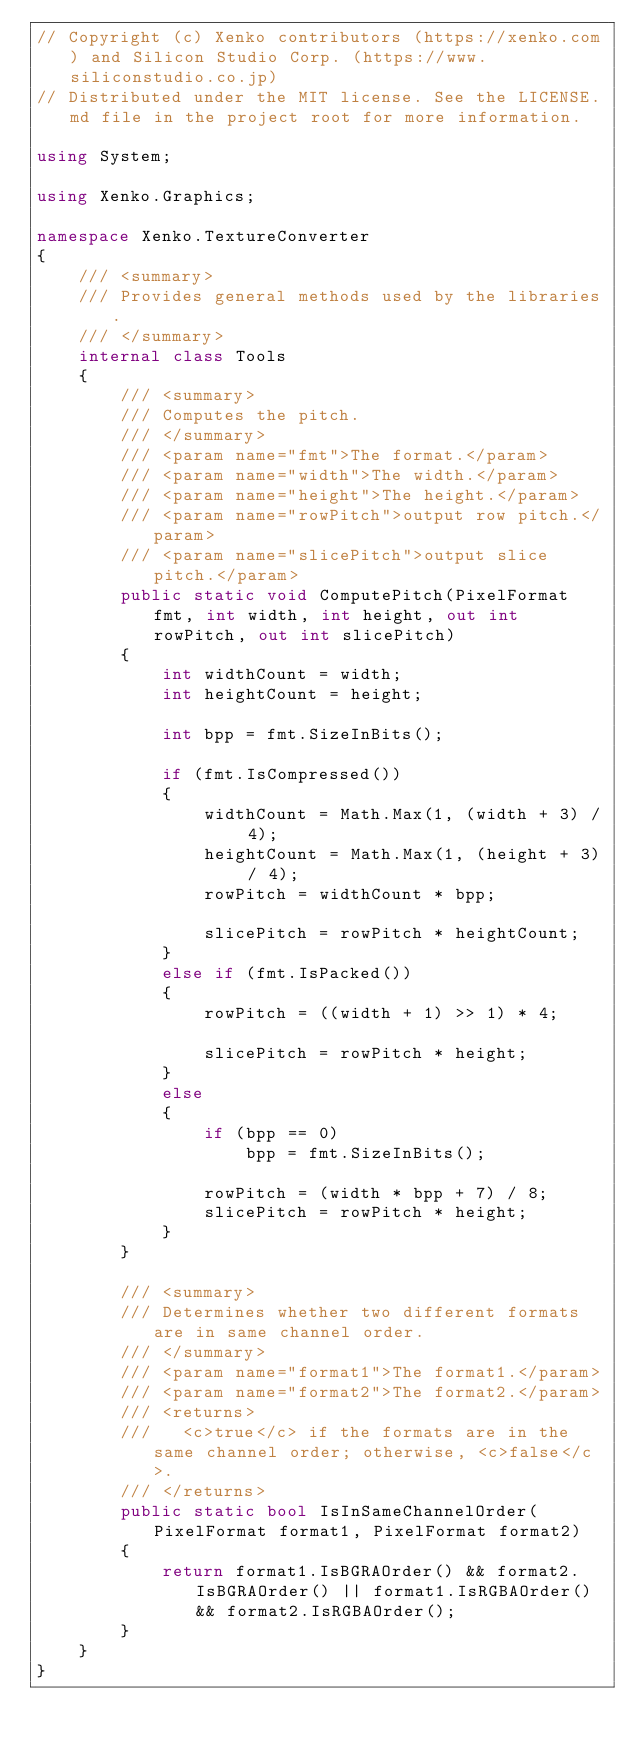<code> <loc_0><loc_0><loc_500><loc_500><_C#_>// Copyright (c) Xenko contributors (https://xenko.com) and Silicon Studio Corp. (https://www.siliconstudio.co.jp)
// Distributed under the MIT license. See the LICENSE.md file in the project root for more information.

using System;

using Xenko.Graphics;

namespace Xenko.TextureConverter
{
    /// <summary>
    /// Provides general methods used by the libraries.
    /// </summary>
    internal class Tools
    {
        /// <summary>
        /// Computes the pitch.
        /// </summary>
        /// <param name="fmt">The format.</param>
        /// <param name="width">The width.</param>
        /// <param name="height">The height.</param>
        /// <param name="rowPitch">output row pitch.</param>
        /// <param name="slicePitch">output slice pitch.</param>
        public static void ComputePitch(PixelFormat fmt, int width, int height, out int rowPitch, out int slicePitch)
        {
            int widthCount = width;
            int heightCount = height;

            int bpp = fmt.SizeInBits();

            if (fmt.IsCompressed())
            {
                widthCount = Math.Max(1, (width + 3) / 4);
                heightCount = Math.Max(1, (height + 3) / 4);
                rowPitch = widthCount * bpp;

                slicePitch = rowPitch * heightCount;
            }
            else if (fmt.IsPacked())
            {
                rowPitch = ((width + 1) >> 1) * 4;

                slicePitch = rowPitch * height;
            }
            else
            {
                if (bpp == 0)
                    bpp = fmt.SizeInBits();

                rowPitch = (width * bpp + 7) / 8;
                slicePitch = rowPitch * height;
            }
        }

        /// <summary>
        /// Determines whether two different formats are in same channel order.
        /// </summary>
        /// <param name="format1">The format1.</param>
        /// <param name="format2">The format2.</param>
        /// <returns>
        ///   <c>true</c> if the formats are in the same channel order; otherwise, <c>false</c>.
        /// </returns>
        public static bool IsInSameChannelOrder(PixelFormat format1, PixelFormat format2)
        {
            return format1.IsBGRAOrder() && format2.IsBGRAOrder() || format1.IsRGBAOrder() && format2.IsRGBAOrder();
        }
    }
}
</code> 